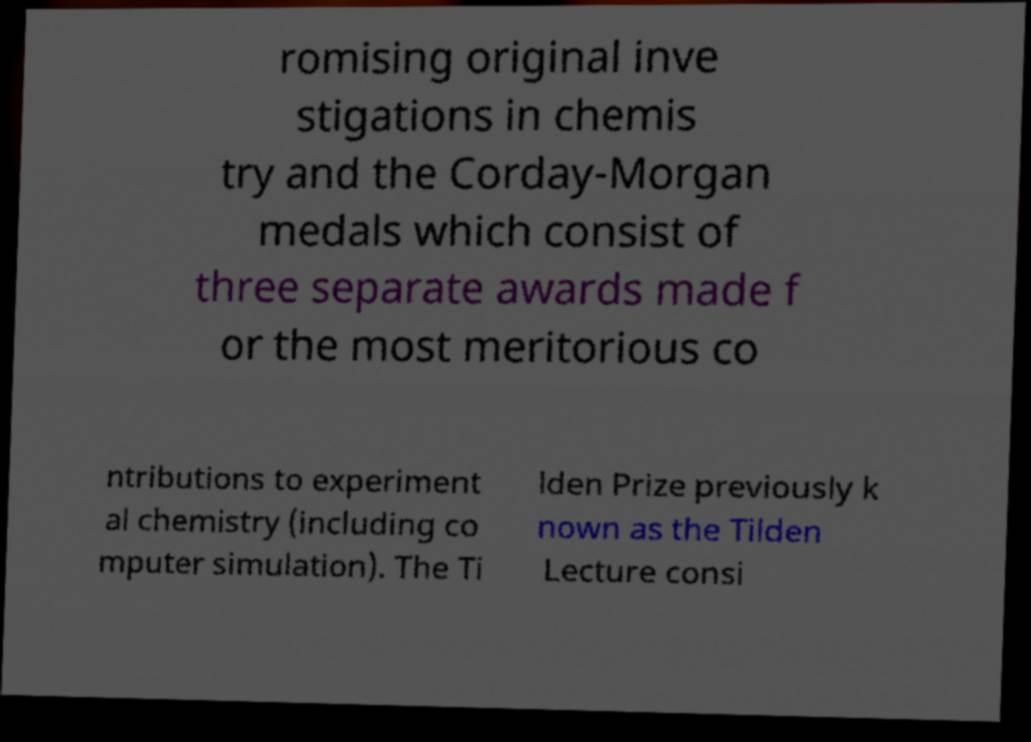Could you extract and type out the text from this image? romising original inve stigations in chemis try and the Corday-Morgan medals which consist of three separate awards made f or the most meritorious co ntributions to experiment al chemistry (including co mputer simulation). The Ti lden Prize previously k nown as the Tilden Lecture consi 